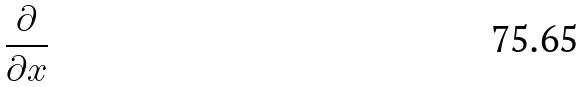<formula> <loc_0><loc_0><loc_500><loc_500>\frac { \partial } { \partial x }</formula> 